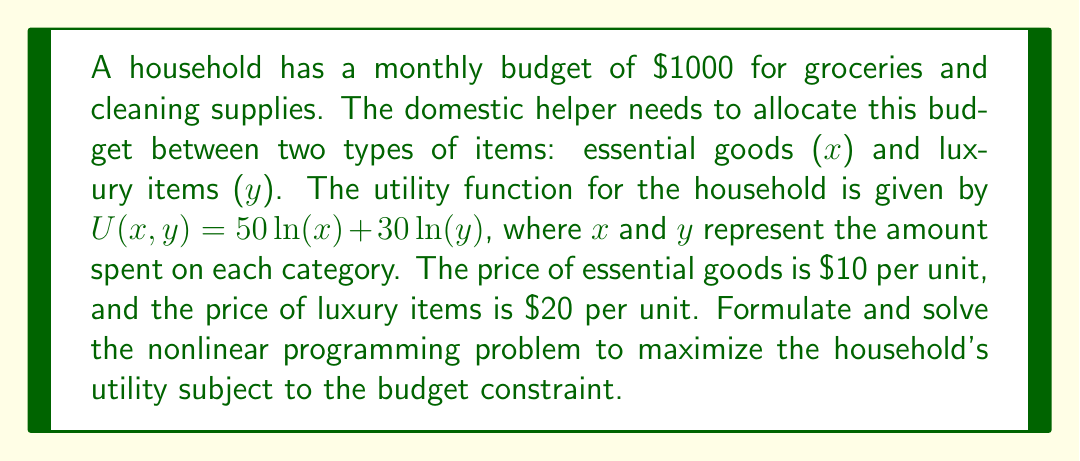Provide a solution to this math problem. 1. Formulate the nonlinear programming problem:

   Maximize: $U(x,y) = 50\ln(x) + 30\ln(y)$
   Subject to: $10x + 20y \leq 1000$ (budget constraint)
               $x \geq 0, y \geq 0$ (non-negativity constraints)

2. Use the Lagrange multiplier method:
   $L(x,y,\lambda) = 50\ln(x) + 30\ln(y) + \lambda(1000 - 10x - 20y)$

3. Find the partial derivatives and set them to zero:
   $\frac{\partial L}{\partial x} = \frac{50}{x} - 10\lambda = 0$
   $\frac{\partial L}{\partial y} = \frac{30}{y} - 20\lambda = 0$
   $\frac{\partial L}{\partial \lambda} = 1000 - 10x - 20y = 0$

4. From the first two equations:
   $\frac{50}{x} = 10\lambda$ and $\frac{30}{y} = 20\lambda$
   $\frac{5}{x} = \frac{3}{2y}$
   $y = \frac{3x}{10}$

5. Substitute this into the budget constraint:
   $1000 = 10x + 20(\frac{3x}{10})$
   $1000 = 10x + 6x = 16x$
   $x = 62.5$

6. Calculate y:
   $y = \frac{3(62.5)}{10} = 18.75$

7. Check the budget constraint:
   $10(62.5) + 20(18.75) = 625 + 375 = 1000$

8. The optimal allocation is:
   Essential goods (x): $625
   Luxury items (y): $375
Answer: Essential goods: $625, Luxury items: $375 